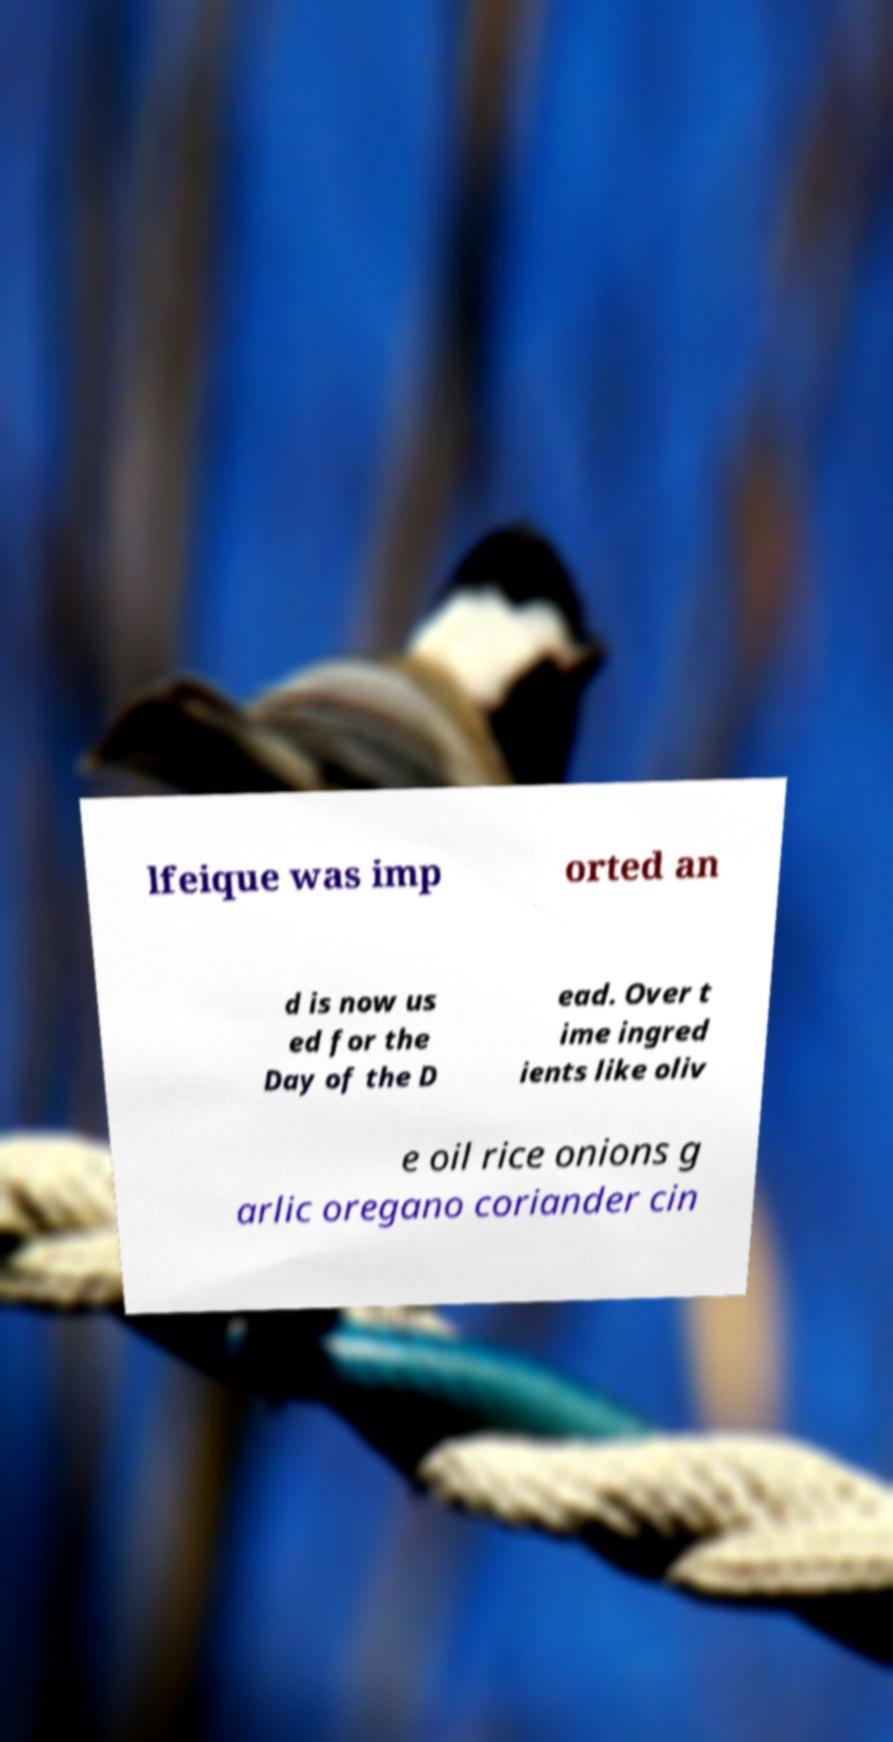Please read and relay the text visible in this image. What does it say? lfeique was imp orted an d is now us ed for the Day of the D ead. Over t ime ingred ients like oliv e oil rice onions g arlic oregano coriander cin 